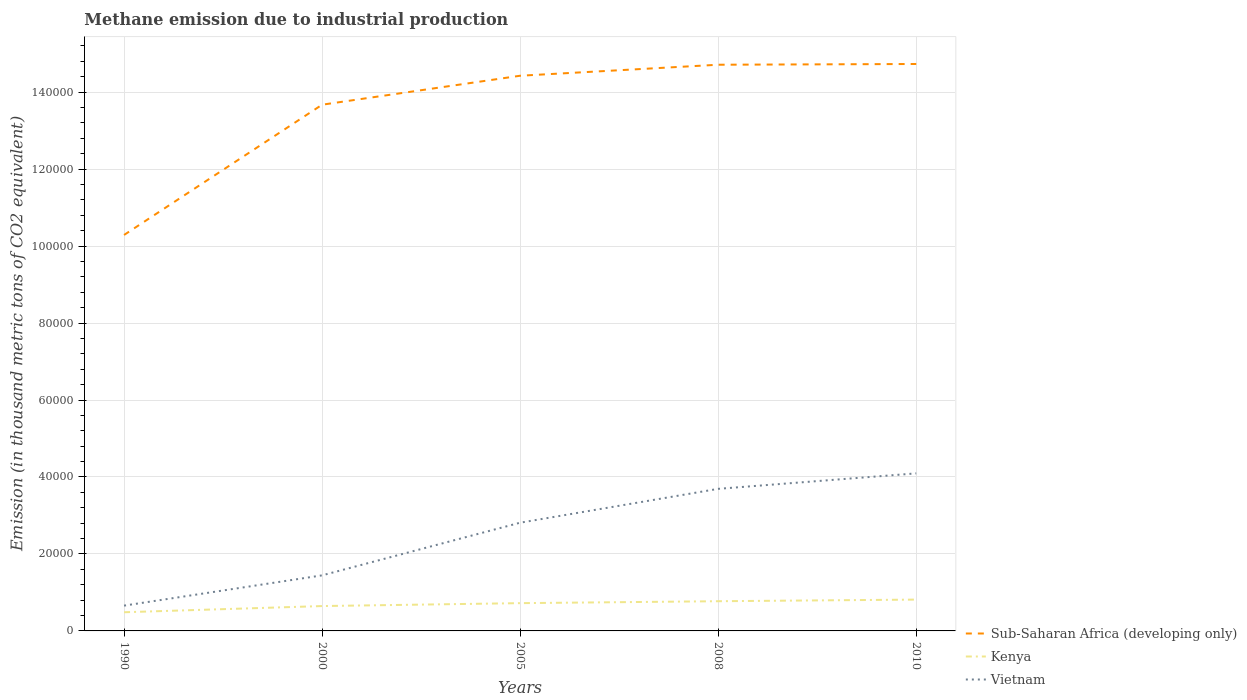Across all years, what is the maximum amount of methane emitted in Kenya?
Provide a succinct answer. 4850.8. In which year was the amount of methane emitted in Sub-Saharan Africa (developing only) maximum?
Your response must be concise. 1990. What is the total amount of methane emitted in Vietnam in the graph?
Ensure brevity in your answer.  -4024.6. What is the difference between the highest and the second highest amount of methane emitted in Sub-Saharan Africa (developing only)?
Ensure brevity in your answer.  4.44e+04. What is the difference between the highest and the lowest amount of methane emitted in Kenya?
Ensure brevity in your answer.  3. How many years are there in the graph?
Your answer should be very brief. 5. What is the difference between two consecutive major ticks on the Y-axis?
Give a very brief answer. 2.00e+04. Does the graph contain any zero values?
Provide a short and direct response. No. What is the title of the graph?
Offer a terse response. Methane emission due to industrial production. Does "Bahrain" appear as one of the legend labels in the graph?
Make the answer very short. No. What is the label or title of the X-axis?
Give a very brief answer. Years. What is the label or title of the Y-axis?
Your answer should be compact. Emission (in thousand metric tons of CO2 equivalent). What is the Emission (in thousand metric tons of CO2 equivalent) of Sub-Saharan Africa (developing only) in 1990?
Offer a very short reply. 1.03e+05. What is the Emission (in thousand metric tons of CO2 equivalent) of Kenya in 1990?
Offer a very short reply. 4850.8. What is the Emission (in thousand metric tons of CO2 equivalent) of Vietnam in 1990?
Your response must be concise. 6574.5. What is the Emission (in thousand metric tons of CO2 equivalent) in Sub-Saharan Africa (developing only) in 2000?
Your answer should be compact. 1.37e+05. What is the Emission (in thousand metric tons of CO2 equivalent) in Kenya in 2000?
Give a very brief answer. 6461.4. What is the Emission (in thousand metric tons of CO2 equivalent) in Vietnam in 2000?
Your answer should be very brief. 1.44e+04. What is the Emission (in thousand metric tons of CO2 equivalent) of Sub-Saharan Africa (developing only) in 2005?
Keep it short and to the point. 1.44e+05. What is the Emission (in thousand metric tons of CO2 equivalent) of Kenya in 2005?
Provide a short and direct response. 7215.9. What is the Emission (in thousand metric tons of CO2 equivalent) of Vietnam in 2005?
Offer a very short reply. 2.81e+04. What is the Emission (in thousand metric tons of CO2 equivalent) of Sub-Saharan Africa (developing only) in 2008?
Your answer should be compact. 1.47e+05. What is the Emission (in thousand metric tons of CO2 equivalent) of Kenya in 2008?
Provide a succinct answer. 7718.1. What is the Emission (in thousand metric tons of CO2 equivalent) of Vietnam in 2008?
Provide a short and direct response. 3.69e+04. What is the Emission (in thousand metric tons of CO2 equivalent) of Sub-Saharan Africa (developing only) in 2010?
Your answer should be very brief. 1.47e+05. What is the Emission (in thousand metric tons of CO2 equivalent) in Kenya in 2010?
Offer a terse response. 8139.1. What is the Emission (in thousand metric tons of CO2 equivalent) of Vietnam in 2010?
Provide a short and direct response. 4.09e+04. Across all years, what is the maximum Emission (in thousand metric tons of CO2 equivalent) of Sub-Saharan Africa (developing only)?
Offer a very short reply. 1.47e+05. Across all years, what is the maximum Emission (in thousand metric tons of CO2 equivalent) in Kenya?
Make the answer very short. 8139.1. Across all years, what is the maximum Emission (in thousand metric tons of CO2 equivalent) of Vietnam?
Your answer should be very brief. 4.09e+04. Across all years, what is the minimum Emission (in thousand metric tons of CO2 equivalent) in Sub-Saharan Africa (developing only)?
Provide a short and direct response. 1.03e+05. Across all years, what is the minimum Emission (in thousand metric tons of CO2 equivalent) of Kenya?
Provide a short and direct response. 4850.8. Across all years, what is the minimum Emission (in thousand metric tons of CO2 equivalent) of Vietnam?
Keep it short and to the point. 6574.5. What is the total Emission (in thousand metric tons of CO2 equivalent) of Sub-Saharan Africa (developing only) in the graph?
Your response must be concise. 6.78e+05. What is the total Emission (in thousand metric tons of CO2 equivalent) of Kenya in the graph?
Provide a short and direct response. 3.44e+04. What is the total Emission (in thousand metric tons of CO2 equivalent) of Vietnam in the graph?
Provide a succinct answer. 1.27e+05. What is the difference between the Emission (in thousand metric tons of CO2 equivalent) of Sub-Saharan Africa (developing only) in 1990 and that in 2000?
Make the answer very short. -3.38e+04. What is the difference between the Emission (in thousand metric tons of CO2 equivalent) of Kenya in 1990 and that in 2000?
Offer a very short reply. -1610.6. What is the difference between the Emission (in thousand metric tons of CO2 equivalent) of Vietnam in 1990 and that in 2000?
Offer a terse response. -7863.6. What is the difference between the Emission (in thousand metric tons of CO2 equivalent) of Sub-Saharan Africa (developing only) in 1990 and that in 2005?
Ensure brevity in your answer.  -4.14e+04. What is the difference between the Emission (in thousand metric tons of CO2 equivalent) in Kenya in 1990 and that in 2005?
Your response must be concise. -2365.1. What is the difference between the Emission (in thousand metric tons of CO2 equivalent) in Vietnam in 1990 and that in 2005?
Provide a short and direct response. -2.15e+04. What is the difference between the Emission (in thousand metric tons of CO2 equivalent) of Sub-Saharan Africa (developing only) in 1990 and that in 2008?
Provide a short and direct response. -4.42e+04. What is the difference between the Emission (in thousand metric tons of CO2 equivalent) in Kenya in 1990 and that in 2008?
Offer a terse response. -2867.3. What is the difference between the Emission (in thousand metric tons of CO2 equivalent) of Vietnam in 1990 and that in 2008?
Ensure brevity in your answer.  -3.03e+04. What is the difference between the Emission (in thousand metric tons of CO2 equivalent) in Sub-Saharan Africa (developing only) in 1990 and that in 2010?
Make the answer very short. -4.44e+04. What is the difference between the Emission (in thousand metric tons of CO2 equivalent) in Kenya in 1990 and that in 2010?
Your answer should be compact. -3288.3. What is the difference between the Emission (in thousand metric tons of CO2 equivalent) in Vietnam in 1990 and that in 2010?
Ensure brevity in your answer.  -3.44e+04. What is the difference between the Emission (in thousand metric tons of CO2 equivalent) in Sub-Saharan Africa (developing only) in 2000 and that in 2005?
Keep it short and to the point. -7528.2. What is the difference between the Emission (in thousand metric tons of CO2 equivalent) in Kenya in 2000 and that in 2005?
Offer a very short reply. -754.5. What is the difference between the Emission (in thousand metric tons of CO2 equivalent) of Vietnam in 2000 and that in 2005?
Your answer should be compact. -1.37e+04. What is the difference between the Emission (in thousand metric tons of CO2 equivalent) in Sub-Saharan Africa (developing only) in 2000 and that in 2008?
Keep it short and to the point. -1.04e+04. What is the difference between the Emission (in thousand metric tons of CO2 equivalent) in Kenya in 2000 and that in 2008?
Make the answer very short. -1256.7. What is the difference between the Emission (in thousand metric tons of CO2 equivalent) in Vietnam in 2000 and that in 2008?
Ensure brevity in your answer.  -2.25e+04. What is the difference between the Emission (in thousand metric tons of CO2 equivalent) of Sub-Saharan Africa (developing only) in 2000 and that in 2010?
Make the answer very short. -1.06e+04. What is the difference between the Emission (in thousand metric tons of CO2 equivalent) of Kenya in 2000 and that in 2010?
Offer a terse response. -1677.7. What is the difference between the Emission (in thousand metric tons of CO2 equivalent) in Vietnam in 2000 and that in 2010?
Your answer should be compact. -2.65e+04. What is the difference between the Emission (in thousand metric tons of CO2 equivalent) in Sub-Saharan Africa (developing only) in 2005 and that in 2008?
Give a very brief answer. -2859.6. What is the difference between the Emission (in thousand metric tons of CO2 equivalent) in Kenya in 2005 and that in 2008?
Keep it short and to the point. -502.2. What is the difference between the Emission (in thousand metric tons of CO2 equivalent) of Vietnam in 2005 and that in 2008?
Your answer should be compact. -8796. What is the difference between the Emission (in thousand metric tons of CO2 equivalent) in Sub-Saharan Africa (developing only) in 2005 and that in 2010?
Provide a succinct answer. -3051.9. What is the difference between the Emission (in thousand metric tons of CO2 equivalent) in Kenya in 2005 and that in 2010?
Your answer should be compact. -923.2. What is the difference between the Emission (in thousand metric tons of CO2 equivalent) in Vietnam in 2005 and that in 2010?
Give a very brief answer. -1.28e+04. What is the difference between the Emission (in thousand metric tons of CO2 equivalent) in Sub-Saharan Africa (developing only) in 2008 and that in 2010?
Keep it short and to the point. -192.3. What is the difference between the Emission (in thousand metric tons of CO2 equivalent) of Kenya in 2008 and that in 2010?
Your answer should be very brief. -421. What is the difference between the Emission (in thousand metric tons of CO2 equivalent) in Vietnam in 2008 and that in 2010?
Your answer should be very brief. -4024.6. What is the difference between the Emission (in thousand metric tons of CO2 equivalent) in Sub-Saharan Africa (developing only) in 1990 and the Emission (in thousand metric tons of CO2 equivalent) in Kenya in 2000?
Ensure brevity in your answer.  9.64e+04. What is the difference between the Emission (in thousand metric tons of CO2 equivalent) of Sub-Saharan Africa (developing only) in 1990 and the Emission (in thousand metric tons of CO2 equivalent) of Vietnam in 2000?
Your answer should be compact. 8.84e+04. What is the difference between the Emission (in thousand metric tons of CO2 equivalent) of Kenya in 1990 and the Emission (in thousand metric tons of CO2 equivalent) of Vietnam in 2000?
Ensure brevity in your answer.  -9587.3. What is the difference between the Emission (in thousand metric tons of CO2 equivalent) of Sub-Saharan Africa (developing only) in 1990 and the Emission (in thousand metric tons of CO2 equivalent) of Kenya in 2005?
Ensure brevity in your answer.  9.57e+04. What is the difference between the Emission (in thousand metric tons of CO2 equivalent) in Sub-Saharan Africa (developing only) in 1990 and the Emission (in thousand metric tons of CO2 equivalent) in Vietnam in 2005?
Ensure brevity in your answer.  7.48e+04. What is the difference between the Emission (in thousand metric tons of CO2 equivalent) of Kenya in 1990 and the Emission (in thousand metric tons of CO2 equivalent) of Vietnam in 2005?
Give a very brief answer. -2.33e+04. What is the difference between the Emission (in thousand metric tons of CO2 equivalent) in Sub-Saharan Africa (developing only) in 1990 and the Emission (in thousand metric tons of CO2 equivalent) in Kenya in 2008?
Give a very brief answer. 9.52e+04. What is the difference between the Emission (in thousand metric tons of CO2 equivalent) in Sub-Saharan Africa (developing only) in 1990 and the Emission (in thousand metric tons of CO2 equivalent) in Vietnam in 2008?
Offer a terse response. 6.60e+04. What is the difference between the Emission (in thousand metric tons of CO2 equivalent) in Kenya in 1990 and the Emission (in thousand metric tons of CO2 equivalent) in Vietnam in 2008?
Give a very brief answer. -3.21e+04. What is the difference between the Emission (in thousand metric tons of CO2 equivalent) in Sub-Saharan Africa (developing only) in 1990 and the Emission (in thousand metric tons of CO2 equivalent) in Kenya in 2010?
Your answer should be compact. 9.47e+04. What is the difference between the Emission (in thousand metric tons of CO2 equivalent) in Sub-Saharan Africa (developing only) in 1990 and the Emission (in thousand metric tons of CO2 equivalent) in Vietnam in 2010?
Ensure brevity in your answer.  6.19e+04. What is the difference between the Emission (in thousand metric tons of CO2 equivalent) of Kenya in 1990 and the Emission (in thousand metric tons of CO2 equivalent) of Vietnam in 2010?
Give a very brief answer. -3.61e+04. What is the difference between the Emission (in thousand metric tons of CO2 equivalent) in Sub-Saharan Africa (developing only) in 2000 and the Emission (in thousand metric tons of CO2 equivalent) in Kenya in 2005?
Your answer should be compact. 1.30e+05. What is the difference between the Emission (in thousand metric tons of CO2 equivalent) of Sub-Saharan Africa (developing only) in 2000 and the Emission (in thousand metric tons of CO2 equivalent) of Vietnam in 2005?
Provide a succinct answer. 1.09e+05. What is the difference between the Emission (in thousand metric tons of CO2 equivalent) in Kenya in 2000 and the Emission (in thousand metric tons of CO2 equivalent) in Vietnam in 2005?
Offer a terse response. -2.17e+04. What is the difference between the Emission (in thousand metric tons of CO2 equivalent) in Sub-Saharan Africa (developing only) in 2000 and the Emission (in thousand metric tons of CO2 equivalent) in Kenya in 2008?
Keep it short and to the point. 1.29e+05. What is the difference between the Emission (in thousand metric tons of CO2 equivalent) in Sub-Saharan Africa (developing only) in 2000 and the Emission (in thousand metric tons of CO2 equivalent) in Vietnam in 2008?
Ensure brevity in your answer.  9.98e+04. What is the difference between the Emission (in thousand metric tons of CO2 equivalent) of Kenya in 2000 and the Emission (in thousand metric tons of CO2 equivalent) of Vietnam in 2008?
Give a very brief answer. -3.05e+04. What is the difference between the Emission (in thousand metric tons of CO2 equivalent) of Sub-Saharan Africa (developing only) in 2000 and the Emission (in thousand metric tons of CO2 equivalent) of Kenya in 2010?
Your answer should be compact. 1.29e+05. What is the difference between the Emission (in thousand metric tons of CO2 equivalent) in Sub-Saharan Africa (developing only) in 2000 and the Emission (in thousand metric tons of CO2 equivalent) in Vietnam in 2010?
Your answer should be very brief. 9.58e+04. What is the difference between the Emission (in thousand metric tons of CO2 equivalent) in Kenya in 2000 and the Emission (in thousand metric tons of CO2 equivalent) in Vietnam in 2010?
Your response must be concise. -3.45e+04. What is the difference between the Emission (in thousand metric tons of CO2 equivalent) of Sub-Saharan Africa (developing only) in 2005 and the Emission (in thousand metric tons of CO2 equivalent) of Kenya in 2008?
Offer a terse response. 1.37e+05. What is the difference between the Emission (in thousand metric tons of CO2 equivalent) of Sub-Saharan Africa (developing only) in 2005 and the Emission (in thousand metric tons of CO2 equivalent) of Vietnam in 2008?
Provide a succinct answer. 1.07e+05. What is the difference between the Emission (in thousand metric tons of CO2 equivalent) in Kenya in 2005 and the Emission (in thousand metric tons of CO2 equivalent) in Vietnam in 2008?
Give a very brief answer. -2.97e+04. What is the difference between the Emission (in thousand metric tons of CO2 equivalent) of Sub-Saharan Africa (developing only) in 2005 and the Emission (in thousand metric tons of CO2 equivalent) of Kenya in 2010?
Provide a succinct answer. 1.36e+05. What is the difference between the Emission (in thousand metric tons of CO2 equivalent) of Sub-Saharan Africa (developing only) in 2005 and the Emission (in thousand metric tons of CO2 equivalent) of Vietnam in 2010?
Provide a short and direct response. 1.03e+05. What is the difference between the Emission (in thousand metric tons of CO2 equivalent) of Kenya in 2005 and the Emission (in thousand metric tons of CO2 equivalent) of Vietnam in 2010?
Give a very brief answer. -3.37e+04. What is the difference between the Emission (in thousand metric tons of CO2 equivalent) in Sub-Saharan Africa (developing only) in 2008 and the Emission (in thousand metric tons of CO2 equivalent) in Kenya in 2010?
Your response must be concise. 1.39e+05. What is the difference between the Emission (in thousand metric tons of CO2 equivalent) of Sub-Saharan Africa (developing only) in 2008 and the Emission (in thousand metric tons of CO2 equivalent) of Vietnam in 2010?
Offer a terse response. 1.06e+05. What is the difference between the Emission (in thousand metric tons of CO2 equivalent) in Kenya in 2008 and the Emission (in thousand metric tons of CO2 equivalent) in Vietnam in 2010?
Ensure brevity in your answer.  -3.32e+04. What is the average Emission (in thousand metric tons of CO2 equivalent) in Sub-Saharan Africa (developing only) per year?
Your response must be concise. 1.36e+05. What is the average Emission (in thousand metric tons of CO2 equivalent) of Kenya per year?
Your response must be concise. 6877.06. What is the average Emission (in thousand metric tons of CO2 equivalent) of Vietnam per year?
Provide a short and direct response. 2.54e+04. In the year 1990, what is the difference between the Emission (in thousand metric tons of CO2 equivalent) in Sub-Saharan Africa (developing only) and Emission (in thousand metric tons of CO2 equivalent) in Kenya?
Give a very brief answer. 9.80e+04. In the year 1990, what is the difference between the Emission (in thousand metric tons of CO2 equivalent) of Sub-Saharan Africa (developing only) and Emission (in thousand metric tons of CO2 equivalent) of Vietnam?
Your response must be concise. 9.63e+04. In the year 1990, what is the difference between the Emission (in thousand metric tons of CO2 equivalent) in Kenya and Emission (in thousand metric tons of CO2 equivalent) in Vietnam?
Provide a succinct answer. -1723.7. In the year 2000, what is the difference between the Emission (in thousand metric tons of CO2 equivalent) in Sub-Saharan Africa (developing only) and Emission (in thousand metric tons of CO2 equivalent) in Kenya?
Offer a terse response. 1.30e+05. In the year 2000, what is the difference between the Emission (in thousand metric tons of CO2 equivalent) of Sub-Saharan Africa (developing only) and Emission (in thousand metric tons of CO2 equivalent) of Vietnam?
Give a very brief answer. 1.22e+05. In the year 2000, what is the difference between the Emission (in thousand metric tons of CO2 equivalent) in Kenya and Emission (in thousand metric tons of CO2 equivalent) in Vietnam?
Give a very brief answer. -7976.7. In the year 2005, what is the difference between the Emission (in thousand metric tons of CO2 equivalent) in Sub-Saharan Africa (developing only) and Emission (in thousand metric tons of CO2 equivalent) in Kenya?
Ensure brevity in your answer.  1.37e+05. In the year 2005, what is the difference between the Emission (in thousand metric tons of CO2 equivalent) in Sub-Saharan Africa (developing only) and Emission (in thousand metric tons of CO2 equivalent) in Vietnam?
Your answer should be compact. 1.16e+05. In the year 2005, what is the difference between the Emission (in thousand metric tons of CO2 equivalent) in Kenya and Emission (in thousand metric tons of CO2 equivalent) in Vietnam?
Offer a very short reply. -2.09e+04. In the year 2008, what is the difference between the Emission (in thousand metric tons of CO2 equivalent) in Sub-Saharan Africa (developing only) and Emission (in thousand metric tons of CO2 equivalent) in Kenya?
Offer a very short reply. 1.39e+05. In the year 2008, what is the difference between the Emission (in thousand metric tons of CO2 equivalent) in Sub-Saharan Africa (developing only) and Emission (in thousand metric tons of CO2 equivalent) in Vietnam?
Offer a terse response. 1.10e+05. In the year 2008, what is the difference between the Emission (in thousand metric tons of CO2 equivalent) of Kenya and Emission (in thousand metric tons of CO2 equivalent) of Vietnam?
Make the answer very short. -2.92e+04. In the year 2010, what is the difference between the Emission (in thousand metric tons of CO2 equivalent) in Sub-Saharan Africa (developing only) and Emission (in thousand metric tons of CO2 equivalent) in Kenya?
Offer a very short reply. 1.39e+05. In the year 2010, what is the difference between the Emission (in thousand metric tons of CO2 equivalent) in Sub-Saharan Africa (developing only) and Emission (in thousand metric tons of CO2 equivalent) in Vietnam?
Offer a very short reply. 1.06e+05. In the year 2010, what is the difference between the Emission (in thousand metric tons of CO2 equivalent) in Kenya and Emission (in thousand metric tons of CO2 equivalent) in Vietnam?
Provide a short and direct response. -3.28e+04. What is the ratio of the Emission (in thousand metric tons of CO2 equivalent) of Sub-Saharan Africa (developing only) in 1990 to that in 2000?
Provide a short and direct response. 0.75. What is the ratio of the Emission (in thousand metric tons of CO2 equivalent) in Kenya in 1990 to that in 2000?
Provide a short and direct response. 0.75. What is the ratio of the Emission (in thousand metric tons of CO2 equivalent) in Vietnam in 1990 to that in 2000?
Your answer should be compact. 0.46. What is the ratio of the Emission (in thousand metric tons of CO2 equivalent) of Sub-Saharan Africa (developing only) in 1990 to that in 2005?
Offer a terse response. 0.71. What is the ratio of the Emission (in thousand metric tons of CO2 equivalent) in Kenya in 1990 to that in 2005?
Make the answer very short. 0.67. What is the ratio of the Emission (in thousand metric tons of CO2 equivalent) in Vietnam in 1990 to that in 2005?
Provide a succinct answer. 0.23. What is the ratio of the Emission (in thousand metric tons of CO2 equivalent) in Sub-Saharan Africa (developing only) in 1990 to that in 2008?
Provide a succinct answer. 0.7. What is the ratio of the Emission (in thousand metric tons of CO2 equivalent) of Kenya in 1990 to that in 2008?
Make the answer very short. 0.63. What is the ratio of the Emission (in thousand metric tons of CO2 equivalent) in Vietnam in 1990 to that in 2008?
Offer a very short reply. 0.18. What is the ratio of the Emission (in thousand metric tons of CO2 equivalent) of Sub-Saharan Africa (developing only) in 1990 to that in 2010?
Offer a terse response. 0.7. What is the ratio of the Emission (in thousand metric tons of CO2 equivalent) in Kenya in 1990 to that in 2010?
Your answer should be very brief. 0.6. What is the ratio of the Emission (in thousand metric tons of CO2 equivalent) of Vietnam in 1990 to that in 2010?
Provide a short and direct response. 0.16. What is the ratio of the Emission (in thousand metric tons of CO2 equivalent) of Sub-Saharan Africa (developing only) in 2000 to that in 2005?
Make the answer very short. 0.95. What is the ratio of the Emission (in thousand metric tons of CO2 equivalent) of Kenya in 2000 to that in 2005?
Give a very brief answer. 0.9. What is the ratio of the Emission (in thousand metric tons of CO2 equivalent) of Vietnam in 2000 to that in 2005?
Ensure brevity in your answer.  0.51. What is the ratio of the Emission (in thousand metric tons of CO2 equivalent) in Sub-Saharan Africa (developing only) in 2000 to that in 2008?
Provide a succinct answer. 0.93. What is the ratio of the Emission (in thousand metric tons of CO2 equivalent) in Kenya in 2000 to that in 2008?
Your response must be concise. 0.84. What is the ratio of the Emission (in thousand metric tons of CO2 equivalent) of Vietnam in 2000 to that in 2008?
Offer a terse response. 0.39. What is the ratio of the Emission (in thousand metric tons of CO2 equivalent) of Sub-Saharan Africa (developing only) in 2000 to that in 2010?
Give a very brief answer. 0.93. What is the ratio of the Emission (in thousand metric tons of CO2 equivalent) of Kenya in 2000 to that in 2010?
Your answer should be very brief. 0.79. What is the ratio of the Emission (in thousand metric tons of CO2 equivalent) of Vietnam in 2000 to that in 2010?
Offer a very short reply. 0.35. What is the ratio of the Emission (in thousand metric tons of CO2 equivalent) in Sub-Saharan Africa (developing only) in 2005 to that in 2008?
Give a very brief answer. 0.98. What is the ratio of the Emission (in thousand metric tons of CO2 equivalent) of Kenya in 2005 to that in 2008?
Ensure brevity in your answer.  0.93. What is the ratio of the Emission (in thousand metric tons of CO2 equivalent) in Vietnam in 2005 to that in 2008?
Your response must be concise. 0.76. What is the ratio of the Emission (in thousand metric tons of CO2 equivalent) in Sub-Saharan Africa (developing only) in 2005 to that in 2010?
Your answer should be compact. 0.98. What is the ratio of the Emission (in thousand metric tons of CO2 equivalent) in Kenya in 2005 to that in 2010?
Your response must be concise. 0.89. What is the ratio of the Emission (in thousand metric tons of CO2 equivalent) in Vietnam in 2005 to that in 2010?
Offer a terse response. 0.69. What is the ratio of the Emission (in thousand metric tons of CO2 equivalent) in Sub-Saharan Africa (developing only) in 2008 to that in 2010?
Your answer should be very brief. 1. What is the ratio of the Emission (in thousand metric tons of CO2 equivalent) in Kenya in 2008 to that in 2010?
Make the answer very short. 0.95. What is the ratio of the Emission (in thousand metric tons of CO2 equivalent) of Vietnam in 2008 to that in 2010?
Offer a very short reply. 0.9. What is the difference between the highest and the second highest Emission (in thousand metric tons of CO2 equivalent) of Sub-Saharan Africa (developing only)?
Your answer should be compact. 192.3. What is the difference between the highest and the second highest Emission (in thousand metric tons of CO2 equivalent) in Kenya?
Keep it short and to the point. 421. What is the difference between the highest and the second highest Emission (in thousand metric tons of CO2 equivalent) in Vietnam?
Make the answer very short. 4024.6. What is the difference between the highest and the lowest Emission (in thousand metric tons of CO2 equivalent) of Sub-Saharan Africa (developing only)?
Keep it short and to the point. 4.44e+04. What is the difference between the highest and the lowest Emission (in thousand metric tons of CO2 equivalent) of Kenya?
Make the answer very short. 3288.3. What is the difference between the highest and the lowest Emission (in thousand metric tons of CO2 equivalent) of Vietnam?
Your response must be concise. 3.44e+04. 